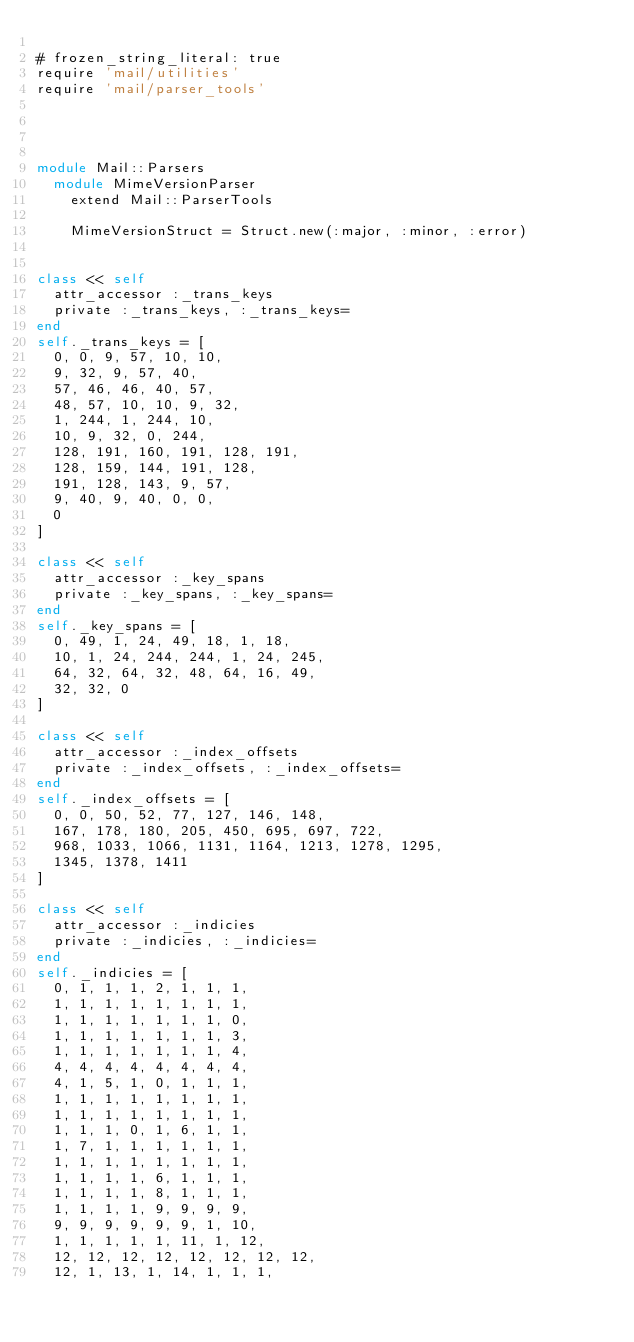<code> <loc_0><loc_0><loc_500><loc_500><_Ruby_>
# frozen_string_literal: true
require 'mail/utilities'
require 'mail/parser_tools'




module Mail::Parsers
  module MimeVersionParser
    extend Mail::ParserTools

    MimeVersionStruct = Struct.new(:major, :minor, :error)

    
class << self
	attr_accessor :_trans_keys
	private :_trans_keys, :_trans_keys=
end
self._trans_keys = [
	0, 0, 9, 57, 10, 10, 
	9, 32, 9, 57, 40, 
	57, 46, 46, 40, 57, 
	48, 57, 10, 10, 9, 32, 
	1, 244, 1, 244, 10, 
	10, 9, 32, 0, 244, 
	128, 191, 160, 191, 128, 191, 
	128, 159, 144, 191, 128, 
	191, 128, 143, 9, 57, 
	9, 40, 9, 40, 0, 0, 
	0
]

class << self
	attr_accessor :_key_spans
	private :_key_spans, :_key_spans=
end
self._key_spans = [
	0, 49, 1, 24, 49, 18, 1, 18, 
	10, 1, 24, 244, 244, 1, 24, 245, 
	64, 32, 64, 32, 48, 64, 16, 49, 
	32, 32, 0
]

class << self
	attr_accessor :_index_offsets
	private :_index_offsets, :_index_offsets=
end
self._index_offsets = [
	0, 0, 50, 52, 77, 127, 146, 148, 
	167, 178, 180, 205, 450, 695, 697, 722, 
	968, 1033, 1066, 1131, 1164, 1213, 1278, 1295, 
	1345, 1378, 1411
]

class << self
	attr_accessor :_indicies
	private :_indicies, :_indicies=
end
self._indicies = [
	0, 1, 1, 1, 2, 1, 1, 1, 
	1, 1, 1, 1, 1, 1, 1, 1, 
	1, 1, 1, 1, 1, 1, 1, 0, 
	1, 1, 1, 1, 1, 1, 1, 3, 
	1, 1, 1, 1, 1, 1, 1, 4, 
	4, 4, 4, 4, 4, 4, 4, 4, 
	4, 1, 5, 1, 0, 1, 1, 1, 
	1, 1, 1, 1, 1, 1, 1, 1, 
	1, 1, 1, 1, 1, 1, 1, 1, 
	1, 1, 1, 0, 1, 6, 1, 1, 
	1, 7, 1, 1, 1, 1, 1, 1, 
	1, 1, 1, 1, 1, 1, 1, 1, 
	1, 1, 1, 1, 6, 1, 1, 1, 
	1, 1, 1, 1, 8, 1, 1, 1, 
	1, 1, 1, 1, 9, 9, 9, 9, 
	9, 9, 9, 9, 9, 9, 1, 10, 
	1, 1, 1, 1, 1, 11, 1, 12, 
	12, 12, 12, 12, 12, 12, 12, 12, 
	12, 1, 13, 1, 14, 1, 1, 1, </code> 